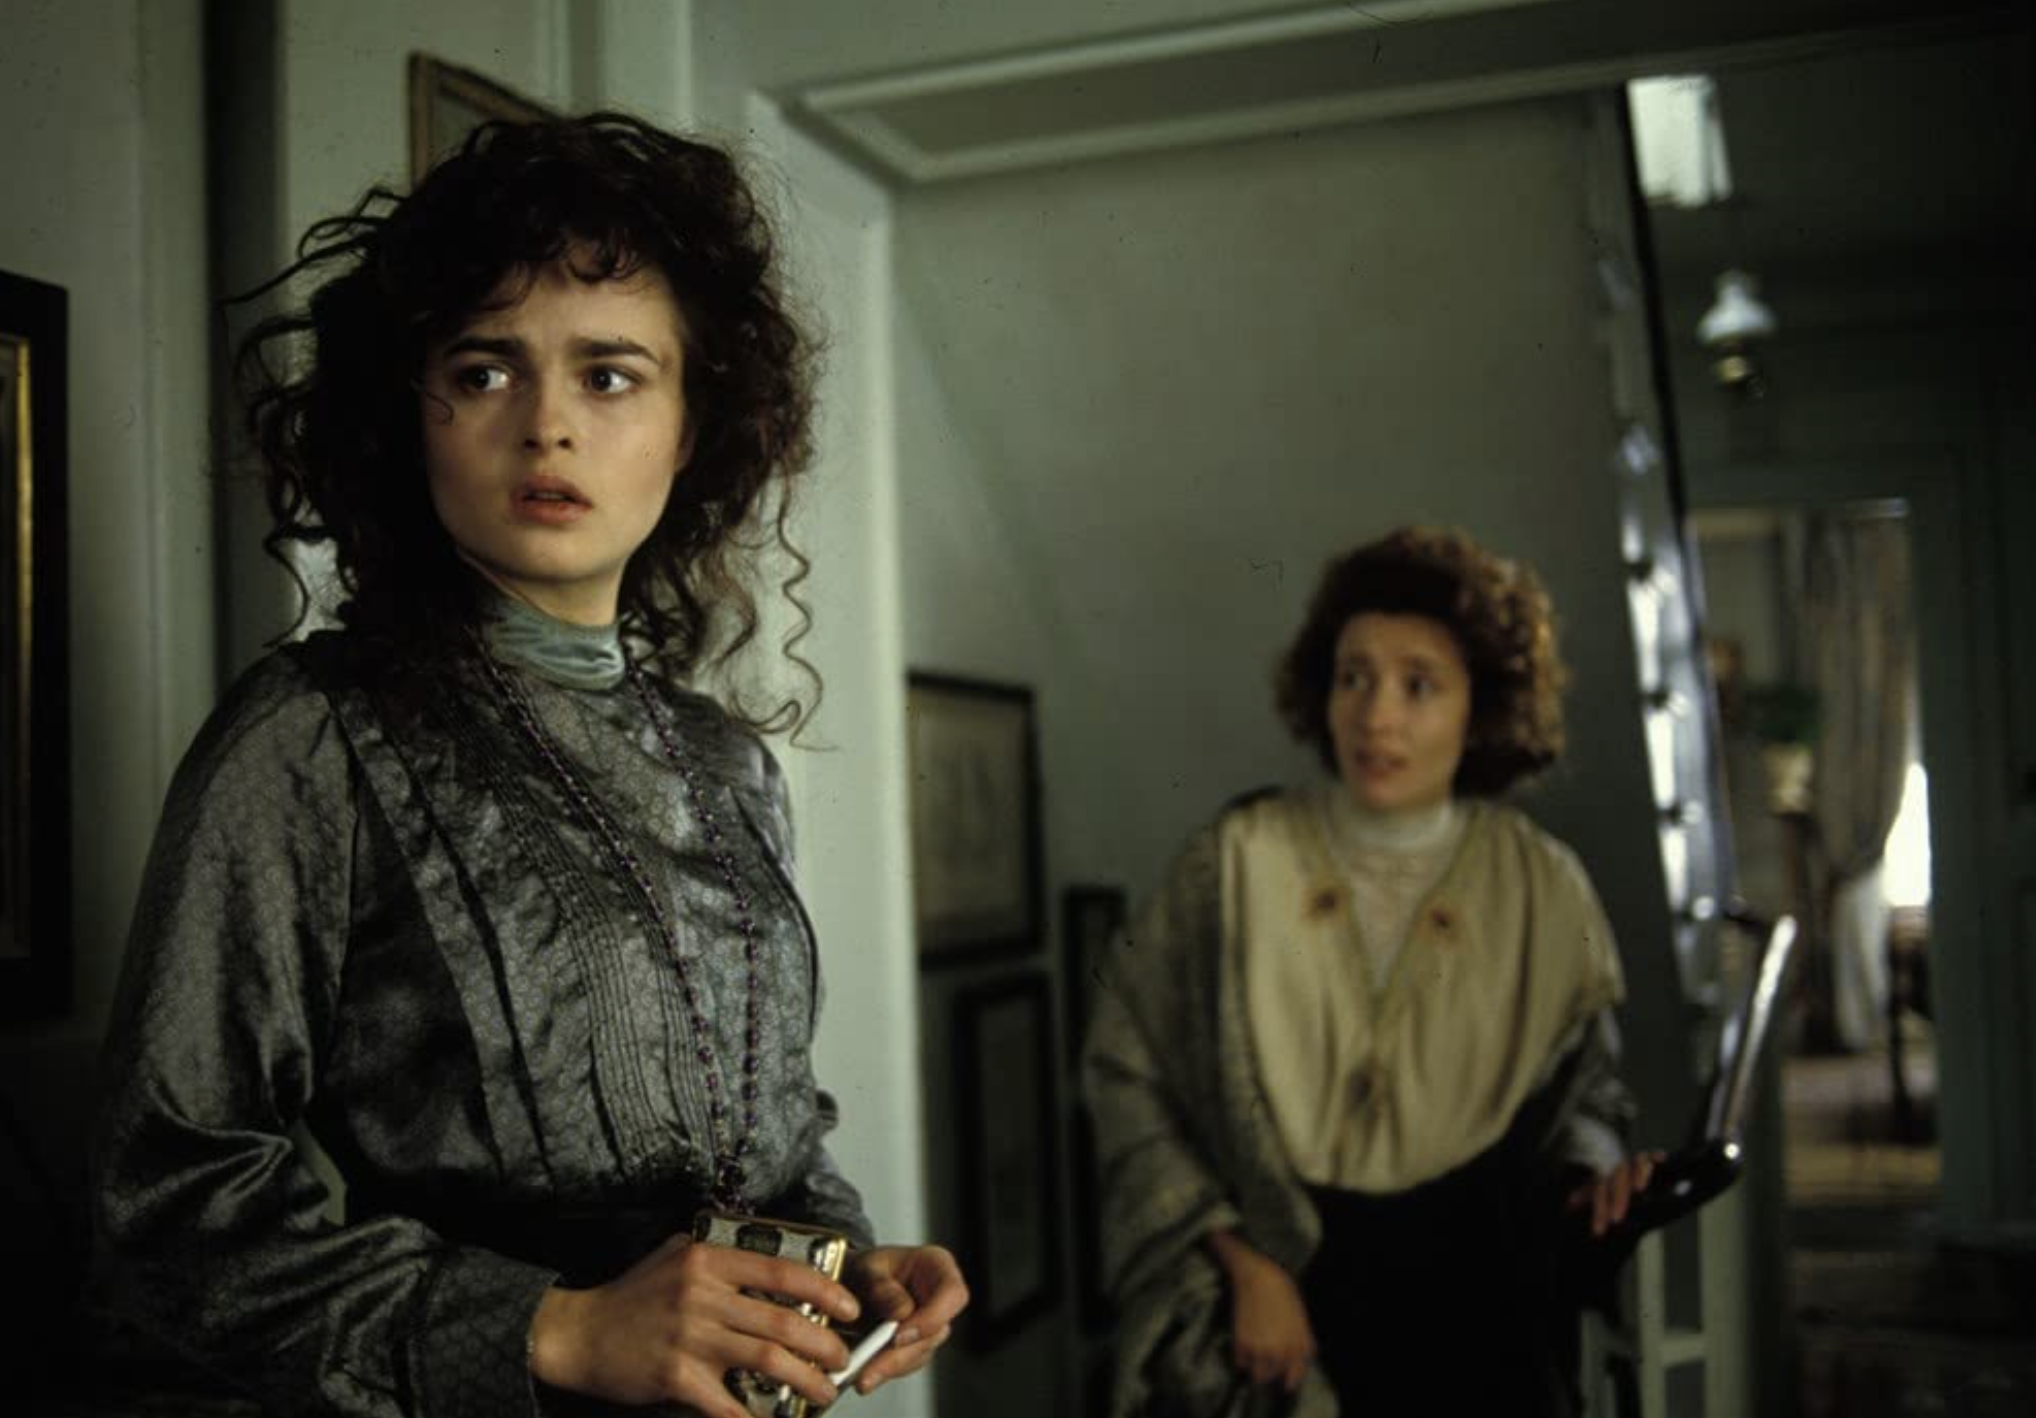Can you describe the emotion conveyed by the person in the foreground? The individual in the foreground exhibits an expression that could be interpreted as worry or contemplation. The slight furrowing of her brow, combined with the sideways gaze, suggests a moment of introspection or concern, possibly about a situation beyond the frame of the photograph. 